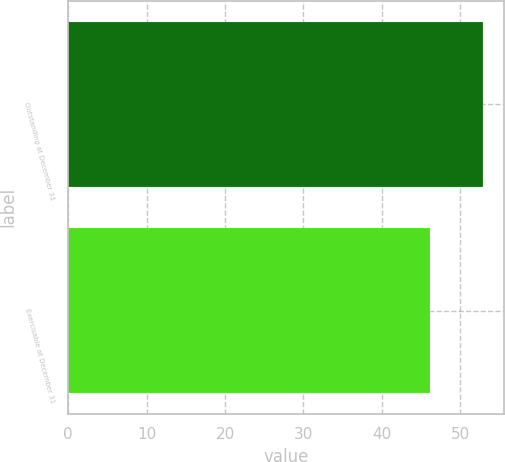Convert chart to OTSL. <chart><loc_0><loc_0><loc_500><loc_500><bar_chart><fcel>Outstanding at December 31<fcel>Exercisable at December 31<nl><fcel>52.87<fcel>46.14<nl></chart> 